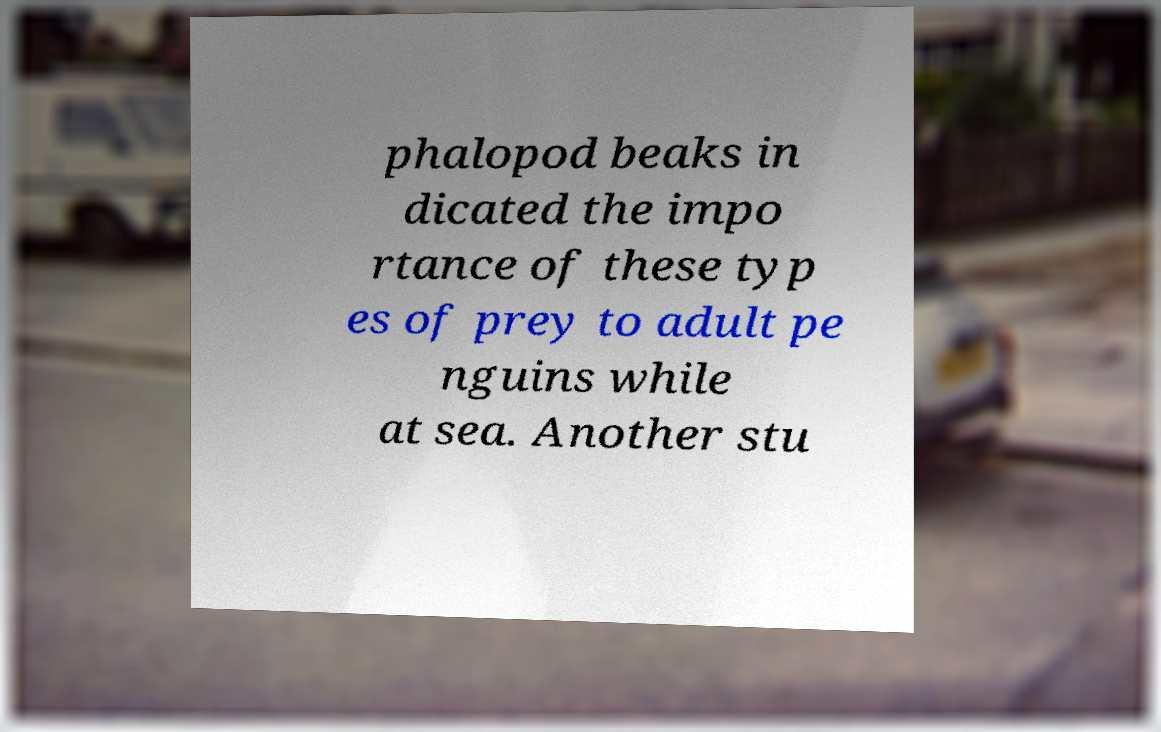There's text embedded in this image that I need extracted. Can you transcribe it verbatim? phalopod beaks in dicated the impo rtance of these typ es of prey to adult pe nguins while at sea. Another stu 